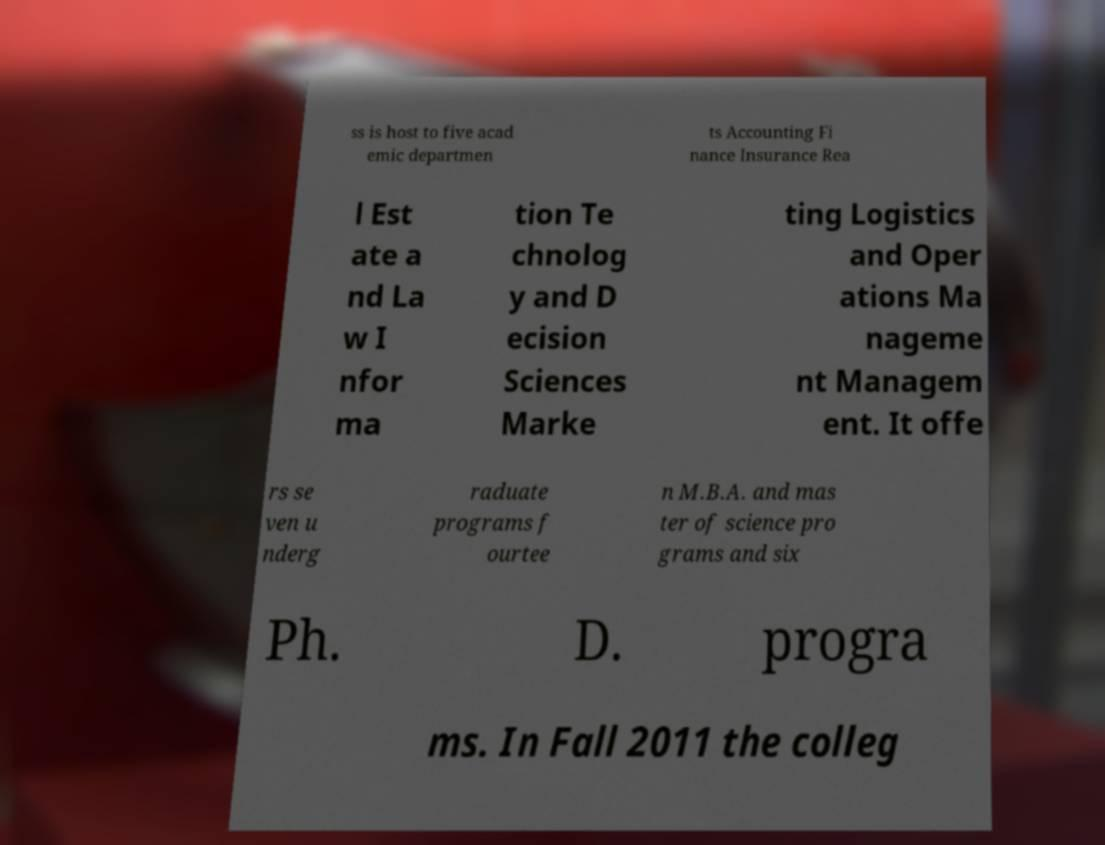For documentation purposes, I need the text within this image transcribed. Could you provide that? ss is host to five acad emic departmen ts Accounting Fi nance Insurance Rea l Est ate a nd La w I nfor ma tion Te chnolog y and D ecision Sciences Marke ting Logistics and Oper ations Ma nageme nt Managem ent. It offe rs se ven u nderg raduate programs f ourtee n M.B.A. and mas ter of science pro grams and six Ph. D. progra ms. In Fall 2011 the colleg 